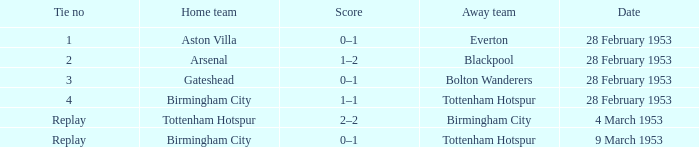Which Score has a Home team of aston villa? 0–1. 